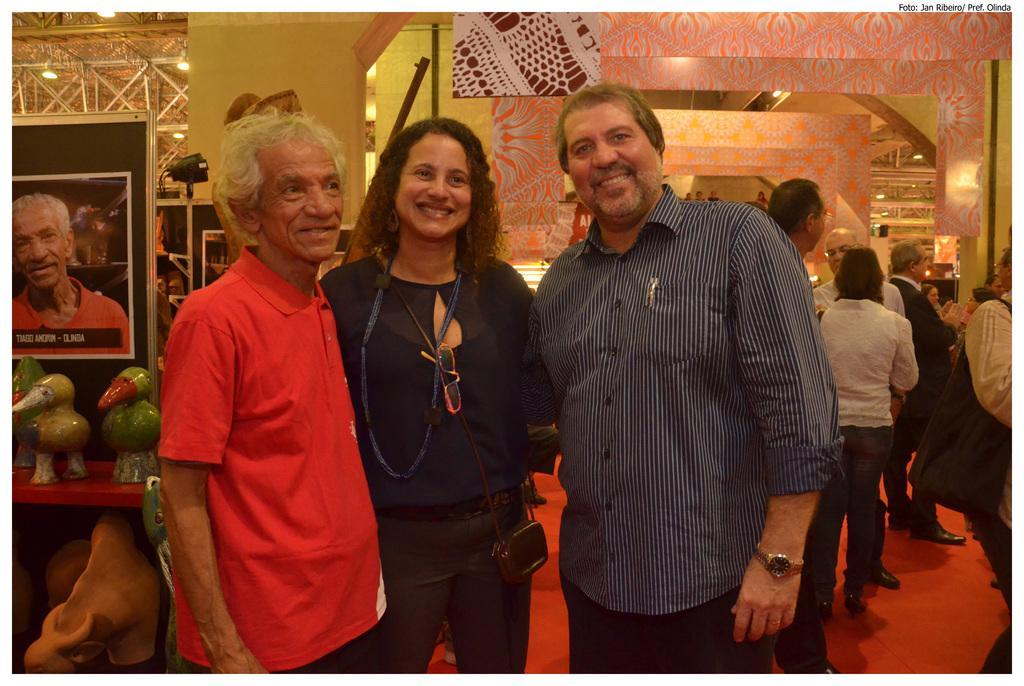Describe this image in one or two sentences. Here in the front we can see three people standing on the floor over there and we can see all of them are smiling and the woman in the front is having a handbag on her and behind them we can see some wooden toys and a portrait present over there and on the right side we can see number of people standing here and there on the floor over there and we can see lights on the roof here and there. 